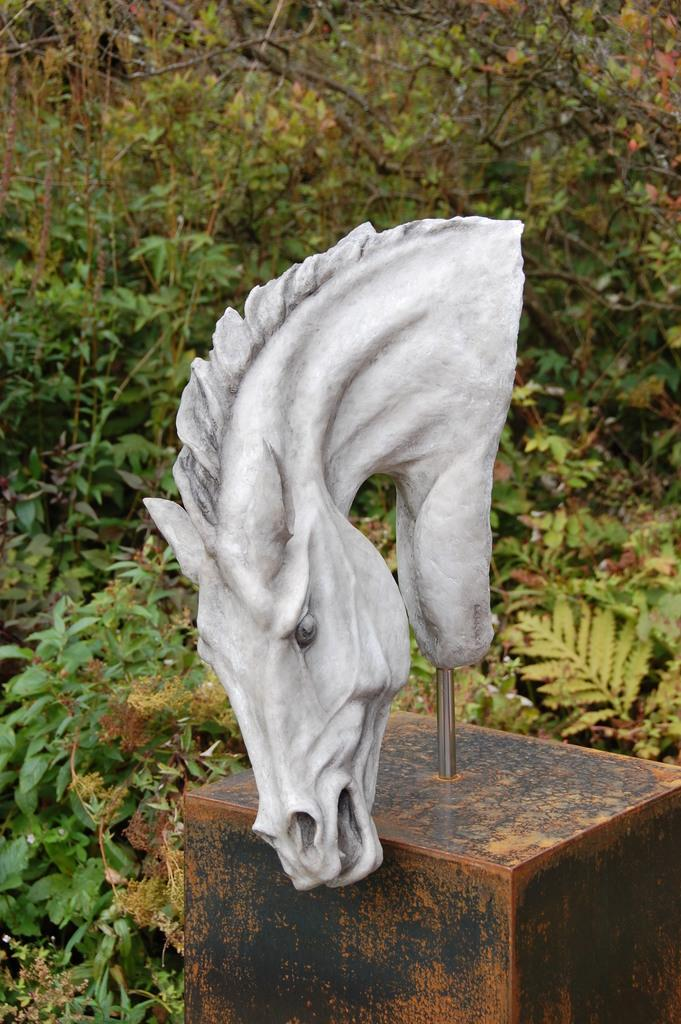What is the main subject of the image? There is an animal sculpture in the image. What feature does the animal sculpture have? The animal sculpture has a rod. What can be seen in the background of the image? There are plants and trees in the background of the image. What type of bottle is being used to solve the riddle in the image? There is no bottle or riddle present in the image. 